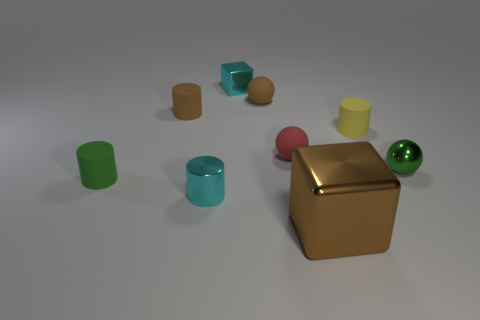What is the material of the thing that is the same color as the metallic cylinder?
Give a very brief answer. Metal. What is the material of the green sphere that is the same size as the yellow object?
Offer a terse response. Metal. Are there any metal cylinders that have the same color as the small block?
Provide a short and direct response. Yes. What shape is the brown object that is both behind the red rubber thing and to the right of the tiny cyan cylinder?
Keep it short and to the point. Sphere. How many small red objects are made of the same material as the cyan block?
Offer a terse response. 0. Are there fewer small yellow objects that are behind the big block than small rubber cylinders behind the tiny red thing?
Provide a succinct answer. Yes. What is the material of the tiny cyan object that is behind the cyan shiny object that is in front of the matte sphere that is behind the small brown cylinder?
Provide a succinct answer. Metal. What size is the metallic thing that is to the right of the small brown sphere and to the left of the tiny yellow thing?
Make the answer very short. Large. What number of cylinders are big yellow rubber objects or tiny green objects?
Make the answer very short. 1. There is a shiny cube that is the same size as the brown rubber cylinder; what color is it?
Offer a terse response. Cyan. 